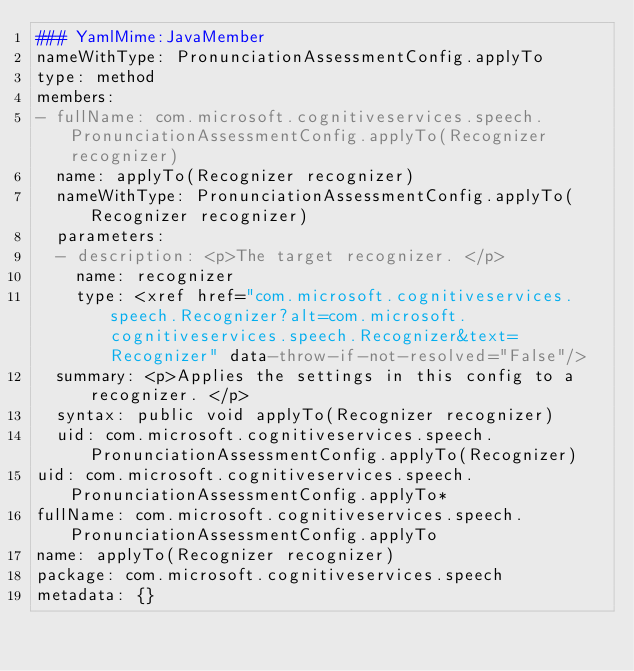<code> <loc_0><loc_0><loc_500><loc_500><_YAML_>### YamlMime:JavaMember
nameWithType: PronunciationAssessmentConfig.applyTo
type: method
members:
- fullName: com.microsoft.cognitiveservices.speech.PronunciationAssessmentConfig.applyTo(Recognizer recognizer)
  name: applyTo(Recognizer recognizer)
  nameWithType: PronunciationAssessmentConfig.applyTo(Recognizer recognizer)
  parameters:
  - description: <p>The target recognizer. </p>
    name: recognizer
    type: <xref href="com.microsoft.cognitiveservices.speech.Recognizer?alt=com.microsoft.cognitiveservices.speech.Recognizer&text=Recognizer" data-throw-if-not-resolved="False"/>
  summary: <p>Applies the settings in this config to a recognizer. </p>
  syntax: public void applyTo(Recognizer recognizer)
  uid: com.microsoft.cognitiveservices.speech.PronunciationAssessmentConfig.applyTo(Recognizer)
uid: com.microsoft.cognitiveservices.speech.PronunciationAssessmentConfig.applyTo*
fullName: com.microsoft.cognitiveservices.speech.PronunciationAssessmentConfig.applyTo
name: applyTo(Recognizer recognizer)
package: com.microsoft.cognitiveservices.speech
metadata: {}
</code> 